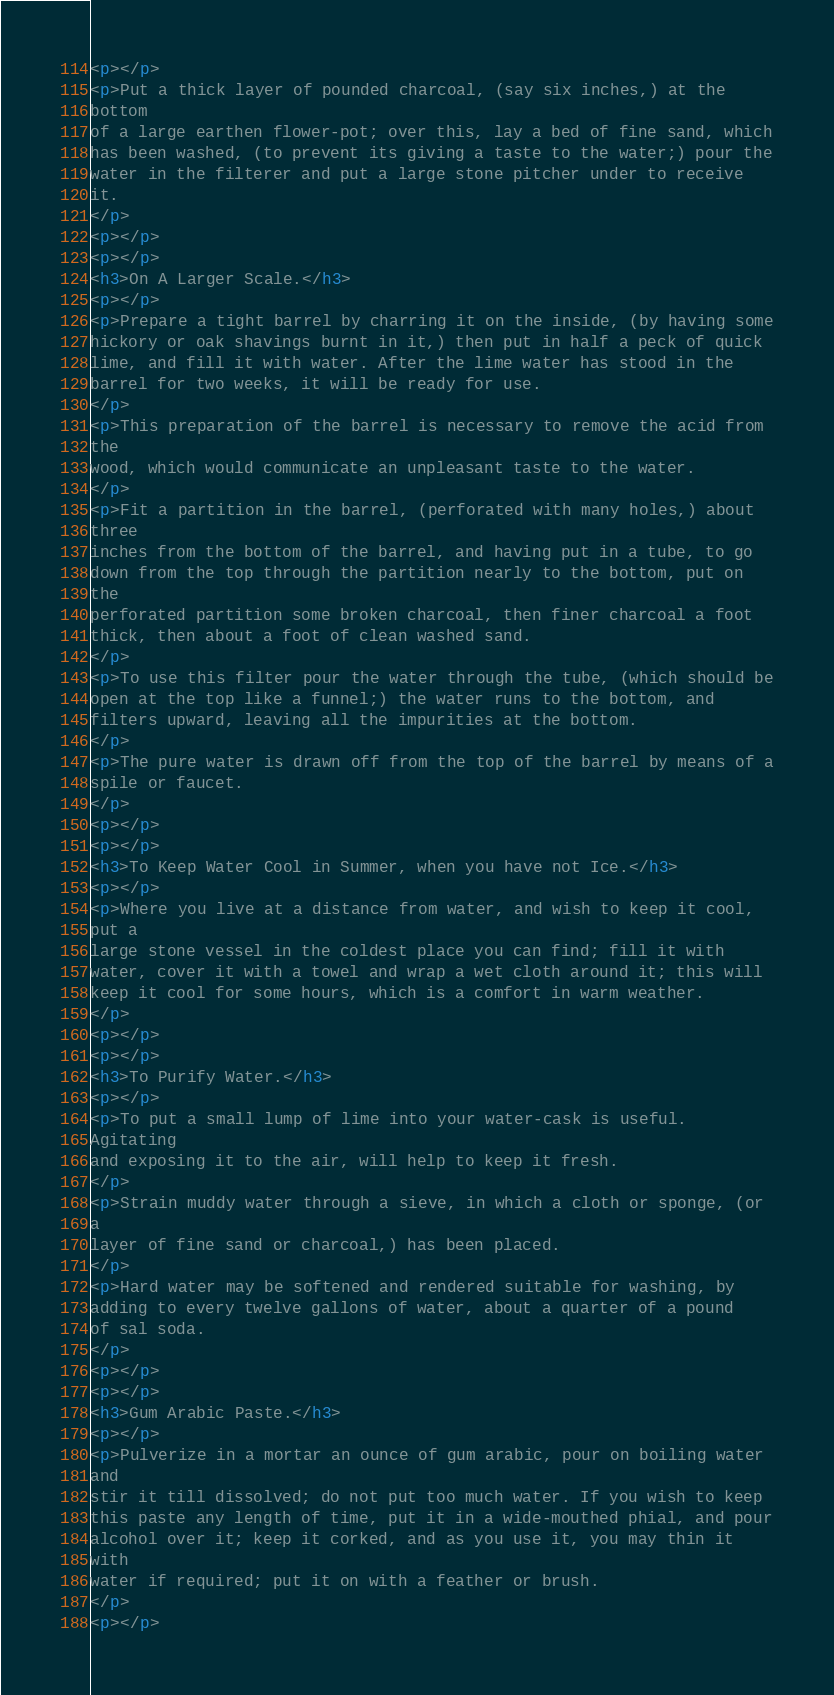<code> <loc_0><loc_0><loc_500><loc_500><_HTML_><p></p>
<p>Put a thick layer of pounded charcoal, (say six inches,) at the
bottom
of a large earthen flower-pot; over this, lay a bed of fine sand, which
has been washed, (to prevent its giving a taste to the water;) pour the
water in the filterer and put a large stone pitcher under to receive
it.
</p>
<p></p>
<p></p>
<h3>On A Larger Scale.</h3>
<p></p>
<p>Prepare a tight barrel by charring it on the inside, (by having some
hickory or oak shavings burnt in it,) then put in half a peck of quick
lime, and fill it with water. After the lime water has stood in the
barrel for two weeks, it will be ready for use.
</p>
<p>This preparation of the barrel is necessary to remove the acid from
the
wood, which would communicate an unpleasant taste to the water.
</p>
<p>Fit a partition in the barrel, (perforated with many holes,) about
three
inches from the bottom of the barrel, and having put in a tube, to go
down from the top through the partition nearly to the bottom, put on
the
perforated partition some broken charcoal, then finer charcoal a foot
thick, then about a foot of clean washed sand.
</p>
<p>To use this filter pour the water through the tube, (which should be
open at the top like a funnel;) the water runs to the bottom, and
filters upward, leaving all the impurities at the bottom.
</p>
<p>The pure water is drawn off from the top of the barrel by means of a
spile or faucet.
</p>
<p></p>
<p></p>
<h3>To Keep Water Cool in Summer, when you have not Ice.</h3>
<p></p>
<p>Where you live at a distance from water, and wish to keep it cool,
put a
large stone vessel in the coldest place you can find; fill it with
water, cover it with a towel and wrap a wet cloth around it; this will
keep it cool for some hours, which is a comfort in warm weather.
</p>
<p></p>
<p></p>
<h3>To Purify Water.</h3>
<p></p>
<p>To put a small lump of lime into your water-cask is useful.
Agitating
and exposing it to the air, will help to keep it fresh.
</p>
<p>Strain muddy water through a sieve, in which a cloth or sponge, (or
a
layer of fine sand or charcoal,) has been placed.
</p>
<p>Hard water may be softened and rendered suitable for washing, by
adding to every twelve gallons of water, about a quarter of a pound
of sal soda.
</p>
<p></p>
<p></p>
<h3>Gum Arabic Paste.</h3>
<p></p>
<p>Pulverize in a mortar an ounce of gum arabic, pour on boiling water
and
stir it till dissolved; do not put too much water. If you wish to keep
this paste any length of time, put it in a wide-mouthed phial, and pour
alcohol over it; keep it corked, and as you use it, you may thin it
with
water if required; put it on with a feather or brush.
</p>
<p></p></code> 